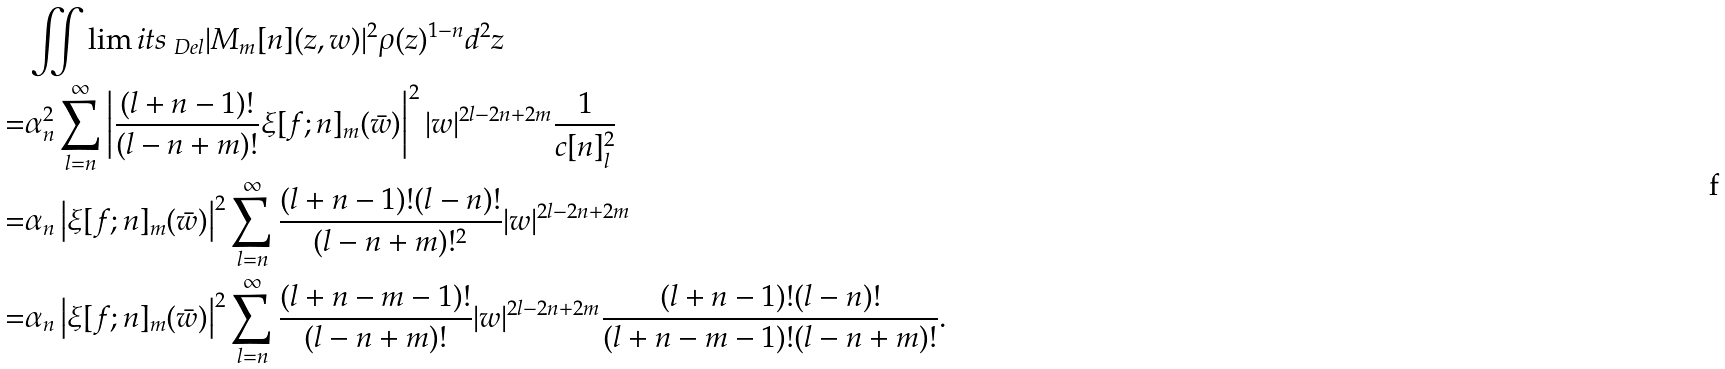<formula> <loc_0><loc_0><loc_500><loc_500>& \iint \lim i t s _ { \ D e l } | M _ { m } [ n ] ( z , w ) | ^ { 2 } \rho ( z ) ^ { 1 - n } d ^ { 2 } z \\ = & \alpha _ { n } ^ { 2 } \sum _ { l = n } ^ { \infty } \left | \frac { ( l + n - 1 ) ! } { ( l - n + m ) ! } \xi [ f ; n ] _ { m } ( \bar { w } ) \right | ^ { 2 } | w | ^ { 2 l - 2 n + 2 m } \frac { 1 } { c [ n ] _ { l } ^ { 2 } } \\ = & \alpha _ { n } \left | \xi [ f ; n ] _ { m } ( \bar { w } ) \right | ^ { 2 } \sum _ { l = n } ^ { \infty } \frac { ( l + n - 1 ) ! ( l - n ) ! } { ( l - n + m ) ! ^ { 2 } } | w | ^ { 2 l - 2 n + 2 m } \\ = & \alpha _ { n } \left | \xi [ f ; n ] _ { m } ( \bar { w } ) \right | ^ { 2 } \sum _ { l = n } ^ { \infty } \frac { ( l + n - m - 1 ) ! } { ( l - n + m ) ! } | w | ^ { 2 l - 2 n + 2 m } \frac { ( l + n - 1 ) ! ( l - n ) ! } { ( l + n - m - 1 ) ! ( l - n + m ) ! } .</formula> 